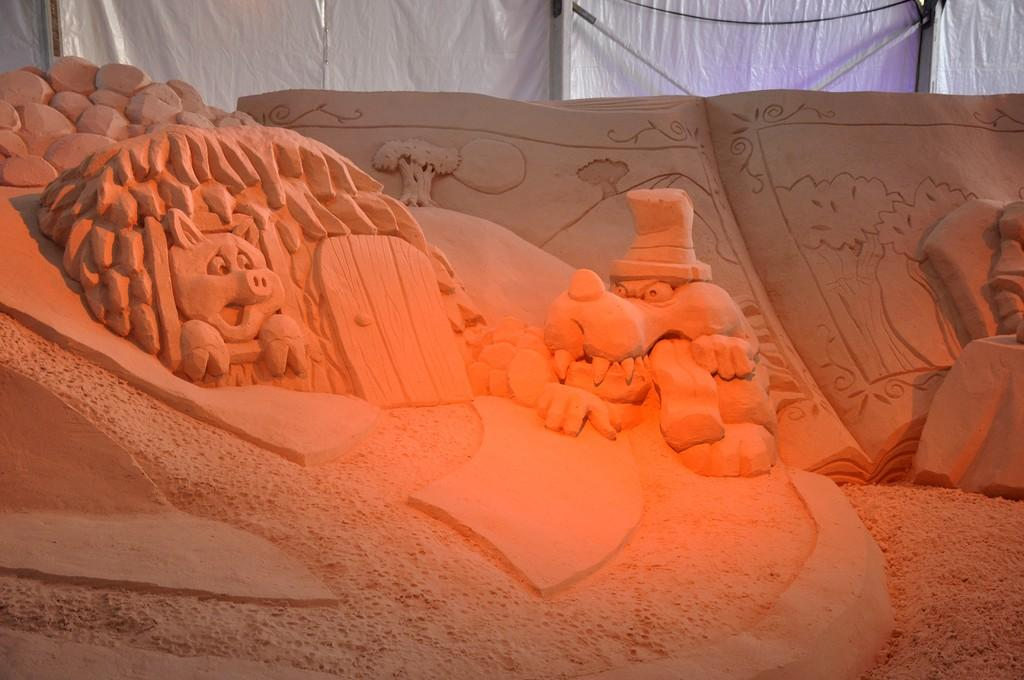What type of art is featured in the image? There is sand art in the image. What can be seen in the background of the image? There is a curtain and poles in the background of the image. Where is the kitty hiding in the image? There is no kitty present in the image. What type of crime is being committed by the crook in the image? There is no crook or crime depicted in the image; it features sand art and background elements. 